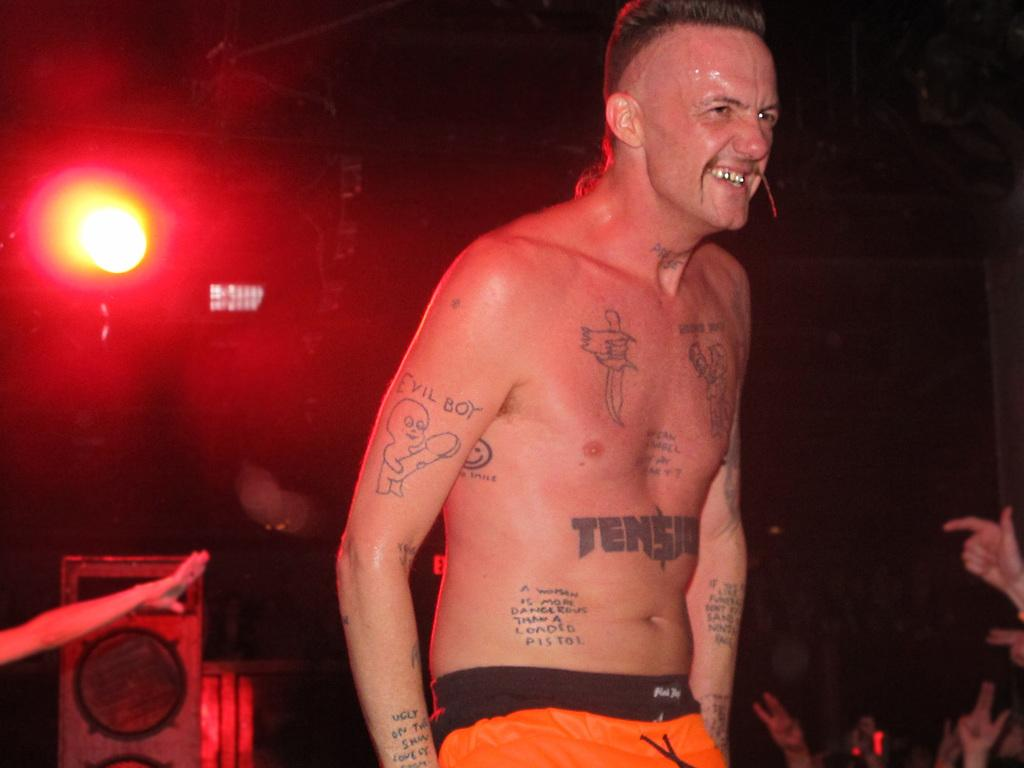What is the person in the front of the image doing? The person is standing and smiling in the front of the image. What can be observed on the person's body? The person has tattoos on their body. What is visible in the background of the image? There are persons, a speaker, and a light in the background of the image. Can you see a rifle in the person's hand in the image? No, there is no rifle present in the image. How many trays are visible in the image? There are no trays visible in the image. 